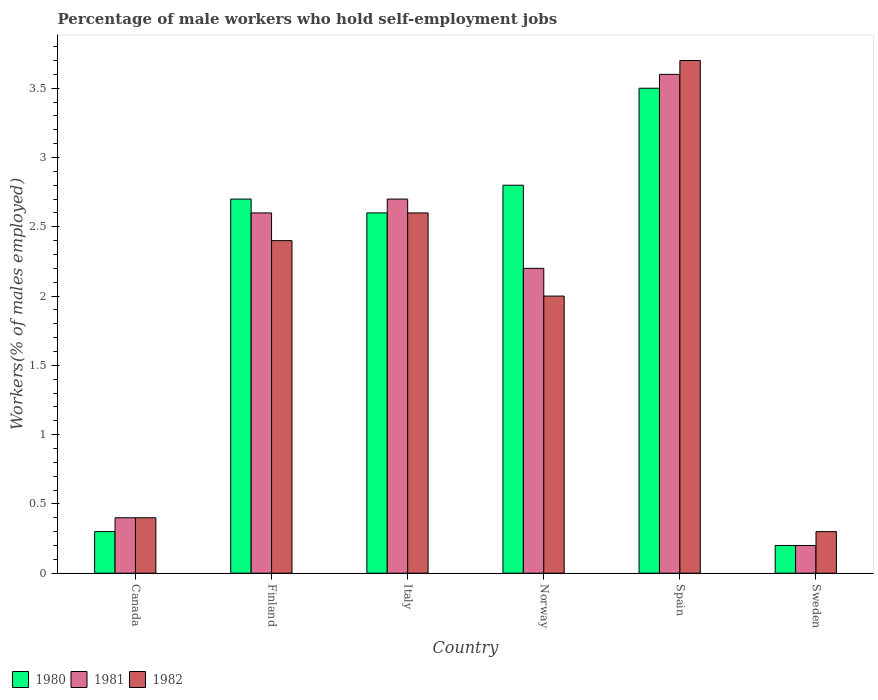How many different coloured bars are there?
Your answer should be compact. 3. Are the number of bars per tick equal to the number of legend labels?
Your answer should be compact. Yes. Are the number of bars on each tick of the X-axis equal?
Provide a short and direct response. Yes. How many bars are there on the 6th tick from the left?
Provide a short and direct response. 3. How many bars are there on the 5th tick from the right?
Your answer should be very brief. 3. What is the percentage of self-employed male workers in 1981 in Canada?
Make the answer very short. 0.4. Across all countries, what is the maximum percentage of self-employed male workers in 1982?
Your response must be concise. 3.7. Across all countries, what is the minimum percentage of self-employed male workers in 1981?
Provide a succinct answer. 0.2. In which country was the percentage of self-employed male workers in 1982 maximum?
Keep it short and to the point. Spain. What is the total percentage of self-employed male workers in 1981 in the graph?
Provide a succinct answer. 11.7. What is the difference between the percentage of self-employed male workers in 1981 in Italy and that in Norway?
Give a very brief answer. 0.5. What is the average percentage of self-employed male workers in 1981 per country?
Give a very brief answer. 1.95. In how many countries, is the percentage of self-employed male workers in 1982 greater than 3.4 %?
Provide a short and direct response. 1. What is the ratio of the percentage of self-employed male workers in 1981 in Finland to that in Italy?
Your response must be concise. 0.96. What is the difference between the highest and the second highest percentage of self-employed male workers in 1982?
Ensure brevity in your answer.  -1.1. What is the difference between the highest and the lowest percentage of self-employed male workers in 1981?
Keep it short and to the point. 3.4. In how many countries, is the percentage of self-employed male workers in 1980 greater than the average percentage of self-employed male workers in 1980 taken over all countries?
Offer a very short reply. 4. What does the 2nd bar from the left in Finland represents?
Offer a very short reply. 1981. How many bars are there?
Offer a terse response. 18. What is the title of the graph?
Provide a short and direct response. Percentage of male workers who hold self-employment jobs. Does "1984" appear as one of the legend labels in the graph?
Provide a short and direct response. No. What is the label or title of the Y-axis?
Provide a succinct answer. Workers(% of males employed). What is the Workers(% of males employed) of 1980 in Canada?
Give a very brief answer. 0.3. What is the Workers(% of males employed) of 1981 in Canada?
Keep it short and to the point. 0.4. What is the Workers(% of males employed) in 1982 in Canada?
Offer a very short reply. 0.4. What is the Workers(% of males employed) in 1980 in Finland?
Your answer should be very brief. 2.7. What is the Workers(% of males employed) of 1981 in Finland?
Keep it short and to the point. 2.6. What is the Workers(% of males employed) of 1982 in Finland?
Make the answer very short. 2.4. What is the Workers(% of males employed) of 1980 in Italy?
Give a very brief answer. 2.6. What is the Workers(% of males employed) in 1981 in Italy?
Provide a short and direct response. 2.7. What is the Workers(% of males employed) of 1982 in Italy?
Your answer should be compact. 2.6. What is the Workers(% of males employed) in 1980 in Norway?
Provide a short and direct response. 2.8. What is the Workers(% of males employed) in 1981 in Norway?
Your answer should be very brief. 2.2. What is the Workers(% of males employed) in 1982 in Norway?
Your response must be concise. 2. What is the Workers(% of males employed) in 1981 in Spain?
Your answer should be very brief. 3.6. What is the Workers(% of males employed) in 1982 in Spain?
Provide a short and direct response. 3.7. What is the Workers(% of males employed) in 1980 in Sweden?
Offer a very short reply. 0.2. What is the Workers(% of males employed) of 1981 in Sweden?
Offer a very short reply. 0.2. What is the Workers(% of males employed) in 1982 in Sweden?
Offer a terse response. 0.3. Across all countries, what is the maximum Workers(% of males employed) of 1980?
Your answer should be very brief. 3.5. Across all countries, what is the maximum Workers(% of males employed) of 1981?
Offer a very short reply. 3.6. Across all countries, what is the maximum Workers(% of males employed) of 1982?
Offer a very short reply. 3.7. Across all countries, what is the minimum Workers(% of males employed) of 1980?
Give a very brief answer. 0.2. Across all countries, what is the minimum Workers(% of males employed) of 1981?
Your response must be concise. 0.2. Across all countries, what is the minimum Workers(% of males employed) in 1982?
Provide a succinct answer. 0.3. What is the total Workers(% of males employed) of 1980 in the graph?
Offer a very short reply. 12.1. What is the total Workers(% of males employed) of 1981 in the graph?
Your response must be concise. 11.7. What is the total Workers(% of males employed) of 1982 in the graph?
Your answer should be very brief. 11.4. What is the difference between the Workers(% of males employed) in 1980 in Canada and that in Finland?
Your response must be concise. -2.4. What is the difference between the Workers(% of males employed) of 1981 in Canada and that in Finland?
Your answer should be compact. -2.2. What is the difference between the Workers(% of males employed) of 1981 in Canada and that in Italy?
Make the answer very short. -2.3. What is the difference between the Workers(% of males employed) of 1980 in Canada and that in Spain?
Offer a terse response. -3.2. What is the difference between the Workers(% of males employed) of 1981 in Canada and that in Spain?
Provide a succinct answer. -3.2. What is the difference between the Workers(% of males employed) in 1982 in Canada and that in Sweden?
Offer a very short reply. 0.1. What is the difference between the Workers(% of males employed) in 1981 in Finland and that in Italy?
Ensure brevity in your answer.  -0.1. What is the difference between the Workers(% of males employed) of 1982 in Finland and that in Italy?
Provide a succinct answer. -0.2. What is the difference between the Workers(% of males employed) in 1980 in Finland and that in Norway?
Your answer should be compact. -0.1. What is the difference between the Workers(% of males employed) of 1981 in Finland and that in Norway?
Your response must be concise. 0.4. What is the difference between the Workers(% of males employed) in 1982 in Finland and that in Norway?
Give a very brief answer. 0.4. What is the difference between the Workers(% of males employed) of 1981 in Italy and that in Norway?
Make the answer very short. 0.5. What is the difference between the Workers(% of males employed) in 1982 in Italy and that in Norway?
Give a very brief answer. 0.6. What is the difference between the Workers(% of males employed) of 1980 in Italy and that in Spain?
Offer a very short reply. -0.9. What is the difference between the Workers(% of males employed) in 1981 in Italy and that in Spain?
Provide a succinct answer. -0.9. What is the difference between the Workers(% of males employed) in 1982 in Italy and that in Spain?
Give a very brief answer. -1.1. What is the difference between the Workers(% of males employed) in 1980 in Italy and that in Sweden?
Provide a short and direct response. 2.4. What is the difference between the Workers(% of males employed) of 1981 in Italy and that in Sweden?
Give a very brief answer. 2.5. What is the difference between the Workers(% of males employed) in 1982 in Italy and that in Sweden?
Give a very brief answer. 2.3. What is the difference between the Workers(% of males employed) of 1980 in Norway and that in Spain?
Ensure brevity in your answer.  -0.7. What is the difference between the Workers(% of males employed) in 1980 in Norway and that in Sweden?
Your answer should be compact. 2.6. What is the difference between the Workers(% of males employed) of 1981 in Norway and that in Sweden?
Offer a terse response. 2. What is the difference between the Workers(% of males employed) of 1980 in Spain and that in Sweden?
Provide a short and direct response. 3.3. What is the difference between the Workers(% of males employed) of 1980 in Canada and the Workers(% of males employed) of 1981 in Finland?
Ensure brevity in your answer.  -2.3. What is the difference between the Workers(% of males employed) in 1980 in Canada and the Workers(% of males employed) in 1982 in Finland?
Provide a short and direct response. -2.1. What is the difference between the Workers(% of males employed) in 1981 in Canada and the Workers(% of males employed) in 1982 in Finland?
Your answer should be compact. -2. What is the difference between the Workers(% of males employed) of 1980 in Canada and the Workers(% of males employed) of 1981 in Italy?
Your answer should be compact. -2.4. What is the difference between the Workers(% of males employed) of 1980 in Canada and the Workers(% of males employed) of 1981 in Norway?
Make the answer very short. -1.9. What is the difference between the Workers(% of males employed) of 1980 in Canada and the Workers(% of males employed) of 1982 in Norway?
Give a very brief answer. -1.7. What is the difference between the Workers(% of males employed) of 1981 in Canada and the Workers(% of males employed) of 1982 in Norway?
Your answer should be very brief. -1.6. What is the difference between the Workers(% of males employed) in 1981 in Canada and the Workers(% of males employed) in 1982 in Spain?
Make the answer very short. -3.3. What is the difference between the Workers(% of males employed) of 1980 in Canada and the Workers(% of males employed) of 1981 in Sweden?
Offer a very short reply. 0.1. What is the difference between the Workers(% of males employed) of 1980 in Canada and the Workers(% of males employed) of 1982 in Sweden?
Your answer should be compact. 0. What is the difference between the Workers(% of males employed) in 1980 in Finland and the Workers(% of males employed) in 1981 in Norway?
Provide a succinct answer. 0.5. What is the difference between the Workers(% of males employed) in 1980 in Finland and the Workers(% of males employed) in 1981 in Spain?
Provide a succinct answer. -0.9. What is the difference between the Workers(% of males employed) in 1980 in Finland and the Workers(% of males employed) in 1982 in Spain?
Your response must be concise. -1. What is the difference between the Workers(% of males employed) in 1981 in Finland and the Workers(% of males employed) in 1982 in Spain?
Provide a short and direct response. -1.1. What is the difference between the Workers(% of males employed) of 1980 in Finland and the Workers(% of males employed) of 1981 in Sweden?
Offer a terse response. 2.5. What is the difference between the Workers(% of males employed) in 1980 in Finland and the Workers(% of males employed) in 1982 in Sweden?
Keep it short and to the point. 2.4. What is the difference between the Workers(% of males employed) in 1981 in Finland and the Workers(% of males employed) in 1982 in Sweden?
Give a very brief answer. 2.3. What is the difference between the Workers(% of males employed) in 1980 in Italy and the Workers(% of males employed) in 1981 in Norway?
Offer a very short reply. 0.4. What is the difference between the Workers(% of males employed) in 1980 in Italy and the Workers(% of males employed) in 1982 in Norway?
Provide a short and direct response. 0.6. What is the difference between the Workers(% of males employed) of 1981 in Italy and the Workers(% of males employed) of 1982 in Norway?
Make the answer very short. 0.7. What is the difference between the Workers(% of males employed) of 1981 in Italy and the Workers(% of males employed) of 1982 in Spain?
Offer a terse response. -1. What is the difference between the Workers(% of males employed) in 1981 in Italy and the Workers(% of males employed) in 1982 in Sweden?
Your answer should be compact. 2.4. What is the difference between the Workers(% of males employed) in 1980 in Norway and the Workers(% of males employed) in 1981 in Sweden?
Give a very brief answer. 2.6. What is the difference between the Workers(% of males employed) in 1980 in Norway and the Workers(% of males employed) in 1982 in Sweden?
Provide a short and direct response. 2.5. What is the difference between the Workers(% of males employed) of 1980 in Spain and the Workers(% of males employed) of 1981 in Sweden?
Offer a terse response. 3.3. What is the difference between the Workers(% of males employed) in 1980 in Spain and the Workers(% of males employed) in 1982 in Sweden?
Provide a short and direct response. 3.2. What is the average Workers(% of males employed) of 1980 per country?
Your answer should be compact. 2.02. What is the average Workers(% of males employed) of 1981 per country?
Provide a succinct answer. 1.95. What is the average Workers(% of males employed) of 1982 per country?
Give a very brief answer. 1.9. What is the difference between the Workers(% of males employed) in 1980 and Workers(% of males employed) in 1981 in Canada?
Keep it short and to the point. -0.1. What is the difference between the Workers(% of males employed) in 1981 and Workers(% of males employed) in 1982 in Finland?
Your response must be concise. 0.2. What is the difference between the Workers(% of males employed) in 1980 and Workers(% of males employed) in 1982 in Italy?
Your answer should be very brief. 0. What is the difference between the Workers(% of males employed) of 1980 and Workers(% of males employed) of 1981 in Norway?
Offer a terse response. 0.6. What is the difference between the Workers(% of males employed) of 1980 and Workers(% of males employed) of 1982 in Norway?
Offer a very short reply. 0.8. What is the difference between the Workers(% of males employed) in 1980 and Workers(% of males employed) in 1982 in Spain?
Provide a short and direct response. -0.2. What is the difference between the Workers(% of males employed) of 1980 and Workers(% of males employed) of 1981 in Sweden?
Provide a succinct answer. 0. What is the ratio of the Workers(% of males employed) of 1981 in Canada to that in Finland?
Keep it short and to the point. 0.15. What is the ratio of the Workers(% of males employed) of 1980 in Canada to that in Italy?
Keep it short and to the point. 0.12. What is the ratio of the Workers(% of males employed) of 1981 in Canada to that in Italy?
Ensure brevity in your answer.  0.15. What is the ratio of the Workers(% of males employed) in 1982 in Canada to that in Italy?
Offer a terse response. 0.15. What is the ratio of the Workers(% of males employed) of 1980 in Canada to that in Norway?
Your response must be concise. 0.11. What is the ratio of the Workers(% of males employed) in 1981 in Canada to that in Norway?
Make the answer very short. 0.18. What is the ratio of the Workers(% of males employed) of 1980 in Canada to that in Spain?
Provide a succinct answer. 0.09. What is the ratio of the Workers(% of males employed) in 1981 in Canada to that in Spain?
Offer a terse response. 0.11. What is the ratio of the Workers(% of males employed) in 1982 in Canada to that in Spain?
Provide a short and direct response. 0.11. What is the ratio of the Workers(% of males employed) of 1982 in Canada to that in Sweden?
Provide a succinct answer. 1.33. What is the ratio of the Workers(% of males employed) of 1981 in Finland to that in Italy?
Offer a terse response. 0.96. What is the ratio of the Workers(% of males employed) of 1980 in Finland to that in Norway?
Ensure brevity in your answer.  0.96. What is the ratio of the Workers(% of males employed) of 1981 in Finland to that in Norway?
Offer a very short reply. 1.18. What is the ratio of the Workers(% of males employed) in 1980 in Finland to that in Spain?
Make the answer very short. 0.77. What is the ratio of the Workers(% of males employed) of 1981 in Finland to that in Spain?
Your answer should be very brief. 0.72. What is the ratio of the Workers(% of males employed) of 1982 in Finland to that in Spain?
Ensure brevity in your answer.  0.65. What is the ratio of the Workers(% of males employed) of 1980 in Finland to that in Sweden?
Ensure brevity in your answer.  13.5. What is the ratio of the Workers(% of males employed) of 1981 in Finland to that in Sweden?
Ensure brevity in your answer.  13. What is the ratio of the Workers(% of males employed) in 1982 in Finland to that in Sweden?
Your answer should be compact. 8. What is the ratio of the Workers(% of males employed) in 1980 in Italy to that in Norway?
Provide a short and direct response. 0.93. What is the ratio of the Workers(% of males employed) in 1981 in Italy to that in Norway?
Offer a terse response. 1.23. What is the ratio of the Workers(% of males employed) of 1980 in Italy to that in Spain?
Provide a short and direct response. 0.74. What is the ratio of the Workers(% of males employed) of 1981 in Italy to that in Spain?
Keep it short and to the point. 0.75. What is the ratio of the Workers(% of males employed) of 1982 in Italy to that in Spain?
Give a very brief answer. 0.7. What is the ratio of the Workers(% of males employed) in 1980 in Italy to that in Sweden?
Your answer should be very brief. 13. What is the ratio of the Workers(% of males employed) in 1982 in Italy to that in Sweden?
Make the answer very short. 8.67. What is the ratio of the Workers(% of males employed) of 1981 in Norway to that in Spain?
Make the answer very short. 0.61. What is the ratio of the Workers(% of males employed) of 1982 in Norway to that in Spain?
Your answer should be compact. 0.54. What is the ratio of the Workers(% of males employed) in 1980 in Spain to that in Sweden?
Keep it short and to the point. 17.5. What is the ratio of the Workers(% of males employed) in 1982 in Spain to that in Sweden?
Provide a short and direct response. 12.33. What is the difference between the highest and the second highest Workers(% of males employed) of 1980?
Your answer should be very brief. 0.7. What is the difference between the highest and the second highest Workers(% of males employed) in 1981?
Your answer should be compact. 0.9. What is the difference between the highest and the second highest Workers(% of males employed) of 1982?
Your answer should be very brief. 1.1. What is the difference between the highest and the lowest Workers(% of males employed) of 1980?
Your answer should be compact. 3.3. What is the difference between the highest and the lowest Workers(% of males employed) of 1981?
Provide a short and direct response. 3.4. What is the difference between the highest and the lowest Workers(% of males employed) in 1982?
Provide a succinct answer. 3.4. 